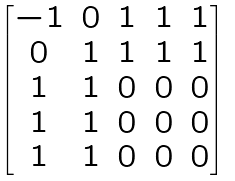<formula> <loc_0><loc_0><loc_500><loc_500>\begin{bmatrix} - 1 & 0 & 1 & 1 & 1 \\ 0 & 1 & 1 & 1 & 1 \\ 1 & 1 & 0 & 0 & 0 \\ 1 & 1 & 0 & 0 & 0 \\ 1 & 1 & 0 & 0 & 0 \end{bmatrix}</formula> 